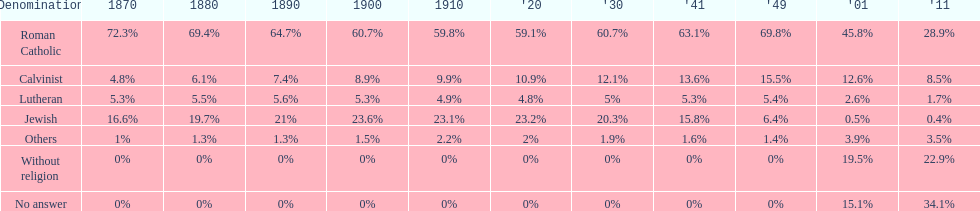Which denomination has the highest margin? Roman Catholic. 